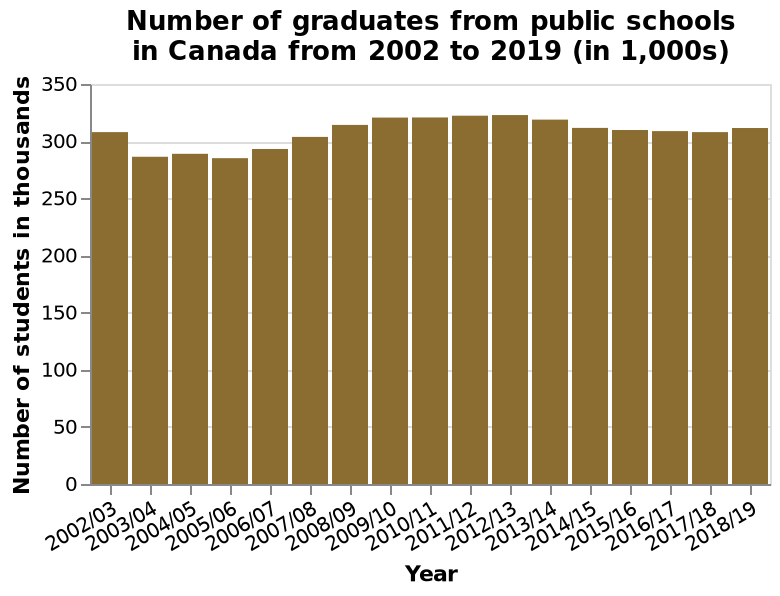<image>
What is the range of the y-axis on the bar diagram?  The range of the y-axis is from 0 to 350 (in thousands). Has there been any significant change in the number of graduates from public schools in Canada between 2015 and 2019?  No, there has not been any significant change in the number of graduates from public schools in Canada between 2015 and 2019. 